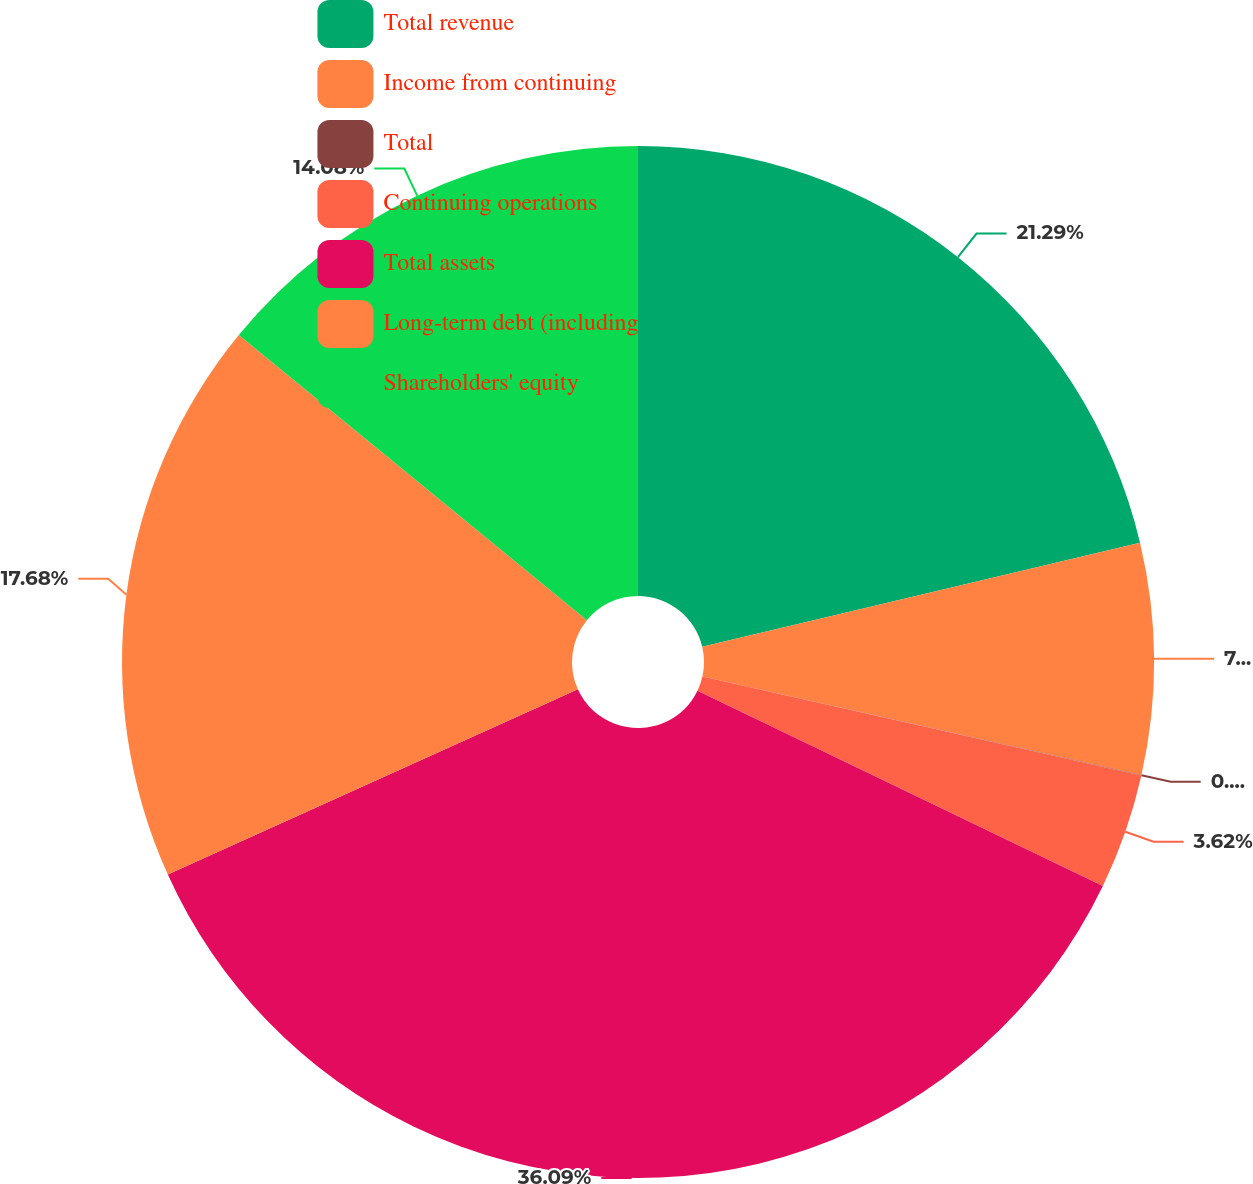Convert chart. <chart><loc_0><loc_0><loc_500><loc_500><pie_chart><fcel>Total revenue<fcel>Income from continuing<fcel>Total<fcel>Continuing operations<fcel>Total assets<fcel>Long-term debt (including<fcel>Shareholders' equity<nl><fcel>21.29%<fcel>7.23%<fcel>0.01%<fcel>3.62%<fcel>36.1%<fcel>17.68%<fcel>14.08%<nl></chart> 